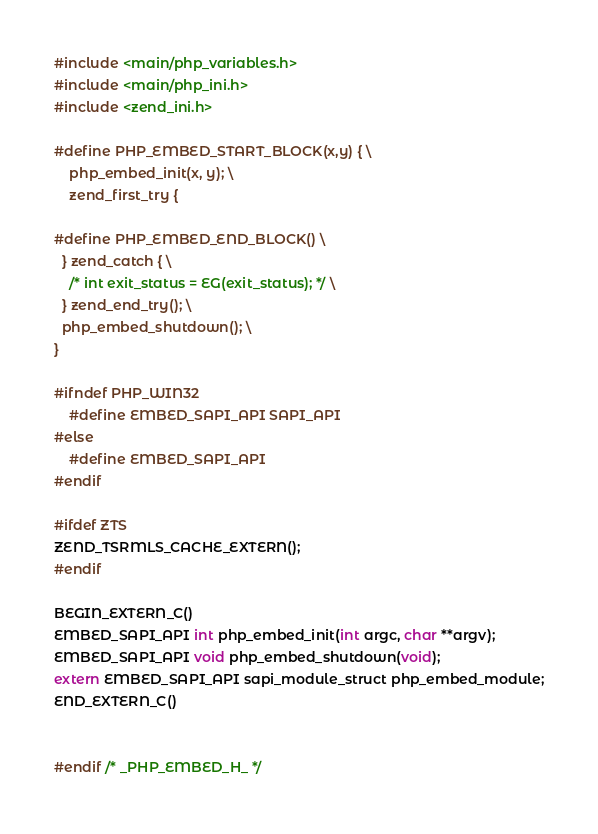Convert code to text. <code><loc_0><loc_0><loc_500><loc_500><_C_>#include <main/php_variables.h>
#include <main/php_ini.h>
#include <zend_ini.h>

#define PHP_EMBED_START_BLOCK(x,y) { \
    php_embed_init(x, y); \
    zend_first_try {

#define PHP_EMBED_END_BLOCK() \
  } zend_catch { \
    /* int exit_status = EG(exit_status); */ \
  } zend_end_try(); \
  php_embed_shutdown(); \
}

#ifndef PHP_WIN32
    #define EMBED_SAPI_API SAPI_API
#else
    #define EMBED_SAPI_API
#endif

#ifdef ZTS
ZEND_TSRMLS_CACHE_EXTERN();
#endif

BEGIN_EXTERN_C()
EMBED_SAPI_API int php_embed_init(int argc, char **argv);
EMBED_SAPI_API void php_embed_shutdown(void);
extern EMBED_SAPI_API sapi_module_struct php_embed_module;
END_EXTERN_C()


#endif /* _PHP_EMBED_H_ */
</code> 